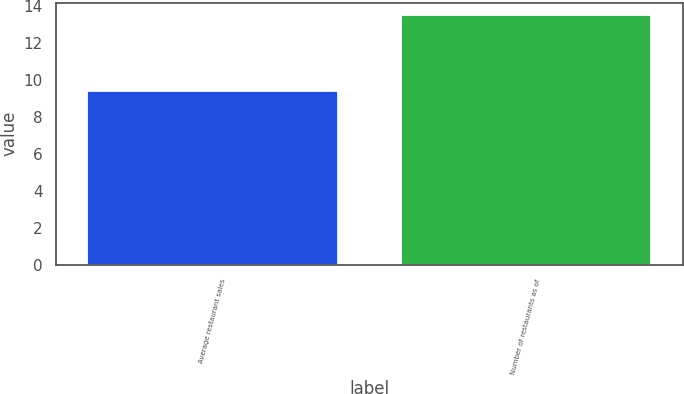Convert chart. <chart><loc_0><loc_0><loc_500><loc_500><bar_chart><fcel>Average restaurant sales<fcel>Number of restaurants as of<nl><fcel>9.4<fcel>13.5<nl></chart> 